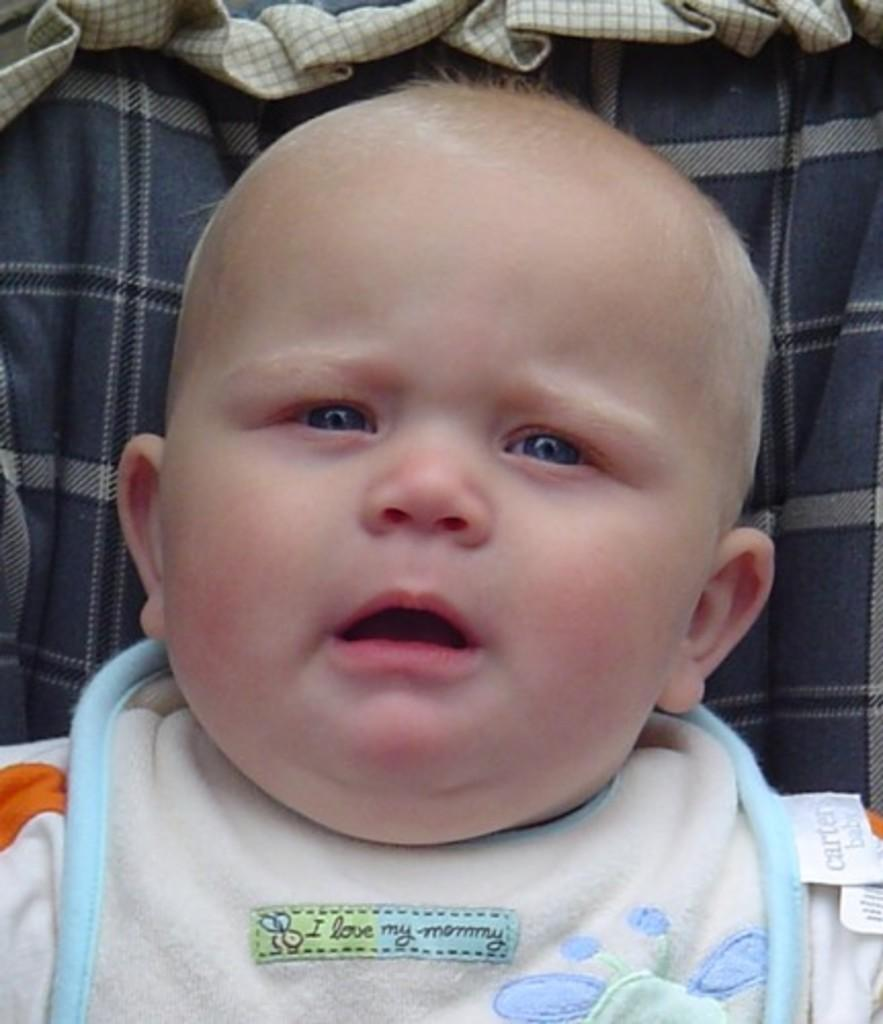What is the main subject of the image? The main subject of the image is a baby. Where is the baby located in the image? The baby is in a trolley. How many dogs are present in the image? There are no dogs visible in the image; the main subject is a baby in a trolley. What type of muscle is being exercised by the baby in the image? The image does not show the baby exercising any muscles; it simply shows the baby in a trolley. 